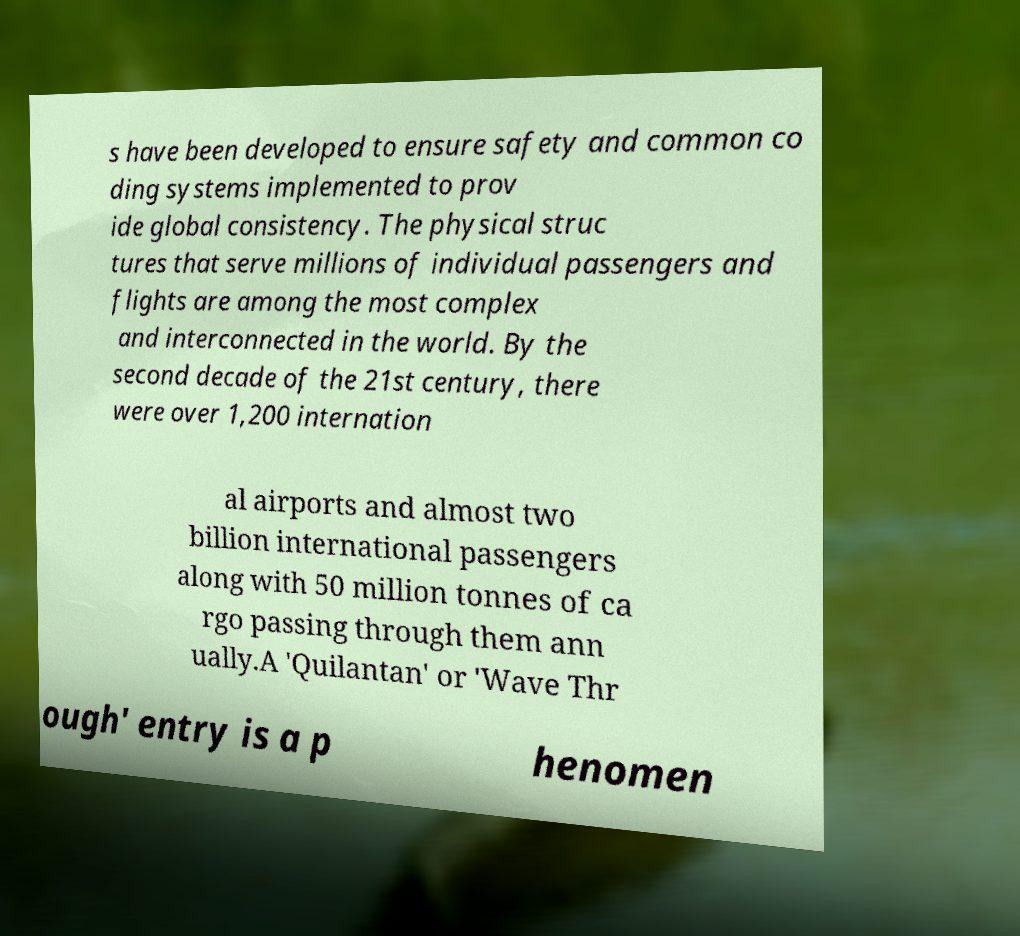Could you extract and type out the text from this image? s have been developed to ensure safety and common co ding systems implemented to prov ide global consistency. The physical struc tures that serve millions of individual passengers and flights are among the most complex and interconnected in the world. By the second decade of the 21st century, there were over 1,200 internation al airports and almost two billion international passengers along with 50 million tonnes of ca rgo passing through them ann ually.A 'Quilantan' or 'Wave Thr ough' entry is a p henomen 